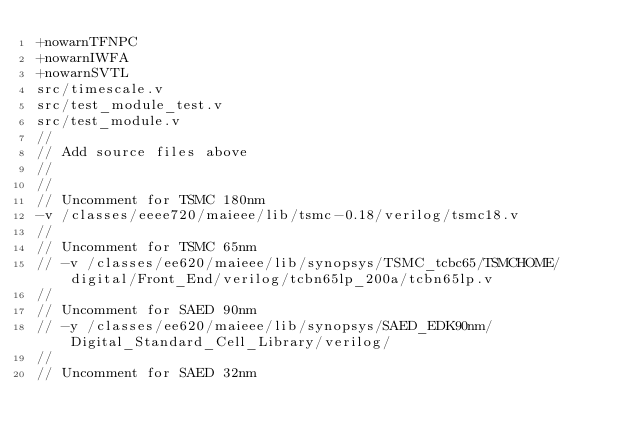<code> <loc_0><loc_0><loc_500><loc_500><_FORTRAN_>+nowarnTFNPC
+nowarnIWFA
+nowarnSVTL
src/timescale.v
src/test_module_test.v
src/test_module.v
//
// Add source files above
//
//
// Uncomment for TSMC 180nm
-v /classes/eeee720/maieee/lib/tsmc-0.18/verilog/tsmc18.v
//
// Uncomment for TSMC 65nm
// -v /classes/ee620/maieee/lib/synopsys/TSMC_tcbc65/TSMCHOME/digital/Front_End/verilog/tcbn65lp_200a/tcbn65lp.v
//
// Uncomment for SAED 90nm
// -y /classes/ee620/maieee/lib/synopsys/SAED_EDK90nm/Digital_Standard_Cell_Library/verilog/
//
// Uncomment for SAED 32nm</code> 